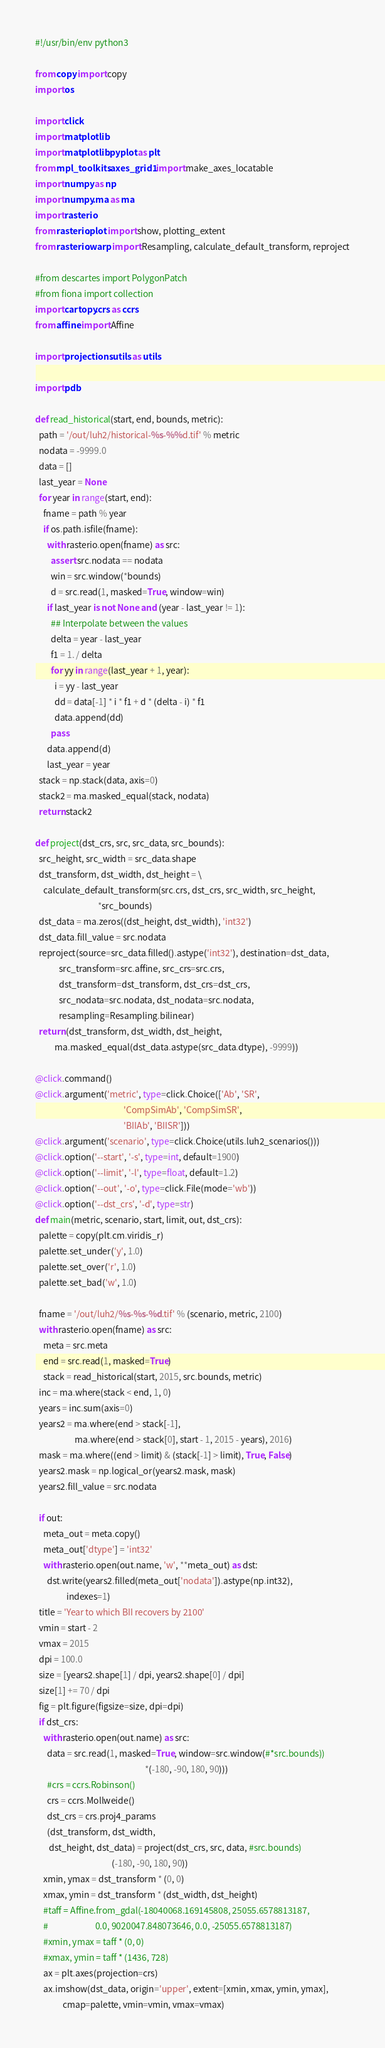Convert code to text. <code><loc_0><loc_0><loc_500><loc_500><_Python_>#!/usr/bin/env python3

from copy import copy
import os

import click
import matplotlib
import matplotlib.pyplot as plt
from mpl_toolkits.axes_grid1 import make_axes_locatable
import numpy as np
import numpy.ma as ma
import rasterio
from rasterio.plot import show, plotting_extent
from rasterio.warp import Resampling, calculate_default_transform, reproject

#from descartes import PolygonPatch
#from fiona import collection
import cartopy.crs as ccrs
from affine import Affine

import projections.utils as utils

import pdb

def read_historical(start, end, bounds, metric):
  path = '/out/luh2/historical-%s-%%d.tif' % metric
  nodata = -9999.0
  data = []
  last_year = None
  for year in range(start, end):
    fname = path % year
    if os.path.isfile(fname):
      with rasterio.open(fname) as src:
        assert src.nodata == nodata
        win = src.window(*bounds)
        d = src.read(1, masked=True, window=win)
      if last_year is not None and (year - last_year != 1):
        ## Interpolate between the values
        delta = year - last_year
        f1 = 1. / delta
        for yy in range(last_year + 1, year):
          i = yy - last_year
          dd = data[-1] * i * f1 + d * (delta - i) * f1
          data.append(dd)
        pass
      data.append(d)
      last_year = year
  stack = np.stack(data, axis=0)
  stack2 = ma.masked_equal(stack, nodata)
  return stack2

def project(dst_crs, src, src_data, src_bounds):
  src_height, src_width = src_data.shape
  dst_transform, dst_width, dst_height = \
    calculate_default_transform(src.crs, dst_crs, src_width, src_height,
                                *src_bounds)
  dst_data = ma.zeros((dst_height, dst_width), 'int32')
  dst_data.fill_value = src.nodata
  reproject(source=src_data.filled().astype('int32'), destination=dst_data,
            src_transform=src.affine, src_crs=src.crs,
            dst_transform=dst_transform, dst_crs=dst_crs,
            src_nodata=src.nodata, dst_nodata=src.nodata,
            resampling=Resampling.bilinear)
  return (dst_transform, dst_width, dst_height,
          ma.masked_equal(dst_data.astype(src_data.dtype), -9999))
            
@click.command()
@click.argument('metric', type=click.Choice(['Ab', 'SR',
                                             'CompSimAb', 'CompSimSR',
                                             'BIIAb', 'BIISR']))
@click.argument('scenario', type=click.Choice(utils.luh2_scenarios()))
@click.option('--start', '-s', type=int, default=1900)
@click.option('--limit', '-l', type=float, default=1.2)
@click.option('--out', '-o', type=click.File(mode='wb'))
@click.option('--dst_crs', '-d', type=str)
def main(metric, scenario, start, limit, out, dst_crs):
  palette = copy(plt.cm.viridis_r)
  palette.set_under('y', 1.0)
  palette.set_over('r', 1.0)
  palette.set_bad('w', 1.0)

  fname = '/out/luh2/%s-%s-%d.tif' % (scenario, metric, 2100)
  with rasterio.open(fname) as src:
    meta = src.meta
    end = src.read(1, masked=True)
    stack = read_historical(start, 2015, src.bounds, metric)
  inc = ma.where(stack < end, 1, 0)
  years = inc.sum(axis=0)
  years2 = ma.where(end > stack[-1],
                    ma.where(end > stack[0], start - 1, 2015 - years), 2016)
  mask = ma.where((end > limit) & (stack[-1] > limit), True, False)
  years2.mask = np.logical_or(years2.mask, mask)
  years2.fill_value = src.nodata
  
  if out:
    meta_out = meta.copy()
    meta_out['dtype'] = 'int32'
    with rasterio.open(out.name, 'w', **meta_out) as dst:
      dst.write(years2.filled(meta_out['nodata']).astype(np.int32),
                indexes=1)
  title = 'Year to which BII recovers by 2100'
  vmin = start - 2
  vmax = 2015
  dpi = 100.0
  size = [years2.shape[1] / dpi, years2.shape[0] / dpi]
  size[1] += 70 / dpi
  fig = plt.figure(figsize=size, dpi=dpi)
  if dst_crs:
    with rasterio.open(out.name) as src:
      data = src.read(1, masked=True, window=src.window(#*src.bounds))
                                                        *(-180, -90, 180, 90)))
      #crs = ccrs.Robinson()
      crs = ccrs.Mollweide()
      dst_crs = crs.proj4_params
      (dst_transform, dst_width,
       dst_height, dst_data) = project(dst_crs, src, data, #src.bounds)
                                       (-180, -90, 180, 90))
    xmin, ymax = dst_transform * (0, 0)
    xmax, ymin = dst_transform * (dst_width, dst_height)
    #taff = Affine.from_gdal(-18040068.169145808, 25055.6578813187,
    #                        0.0, 9020047.848073646, 0.0, -25055.6578813187)
    #xmin, ymax = taff * (0, 0)
    #xmax, ymin = taff * (1436, 728)
    ax = plt.axes(projection=crs)
    ax.imshow(dst_data, origin='upper', extent=[xmin, xmax, ymin, ymax],
              cmap=palette, vmin=vmin, vmax=vmax)</code> 